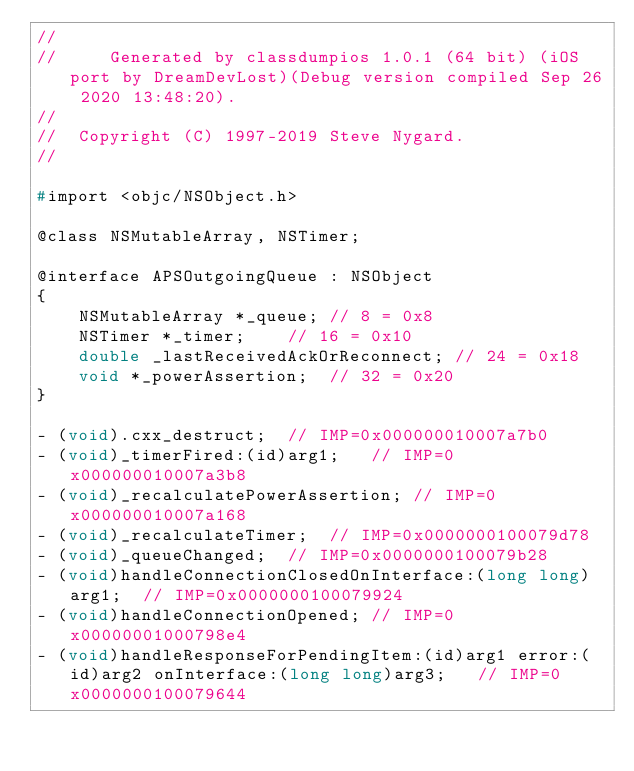<code> <loc_0><loc_0><loc_500><loc_500><_C_>//
//     Generated by classdumpios 1.0.1 (64 bit) (iOS port by DreamDevLost)(Debug version compiled Sep 26 2020 13:48:20).
//
//  Copyright (C) 1997-2019 Steve Nygard.
//

#import <objc/NSObject.h>

@class NSMutableArray, NSTimer;

@interface APSOutgoingQueue : NSObject
{
    NSMutableArray *_queue;	// 8 = 0x8
    NSTimer *_timer;	// 16 = 0x10
    double _lastReceivedAckOrReconnect;	// 24 = 0x18
    void *_powerAssertion;	// 32 = 0x20
}

- (void).cxx_destruct;	// IMP=0x000000010007a7b0
- (void)_timerFired:(id)arg1;	// IMP=0x000000010007a3b8
- (void)_recalculatePowerAssertion;	// IMP=0x000000010007a168
- (void)_recalculateTimer;	// IMP=0x0000000100079d78
- (void)_queueChanged;	// IMP=0x0000000100079b28
- (void)handleConnectionClosedOnInterface:(long long)arg1;	// IMP=0x0000000100079924
- (void)handleConnectionOpened;	// IMP=0x00000001000798e4
- (void)handleResponseForPendingItem:(id)arg1 error:(id)arg2 onInterface:(long long)arg3;	// IMP=0x0000000100079644</code> 